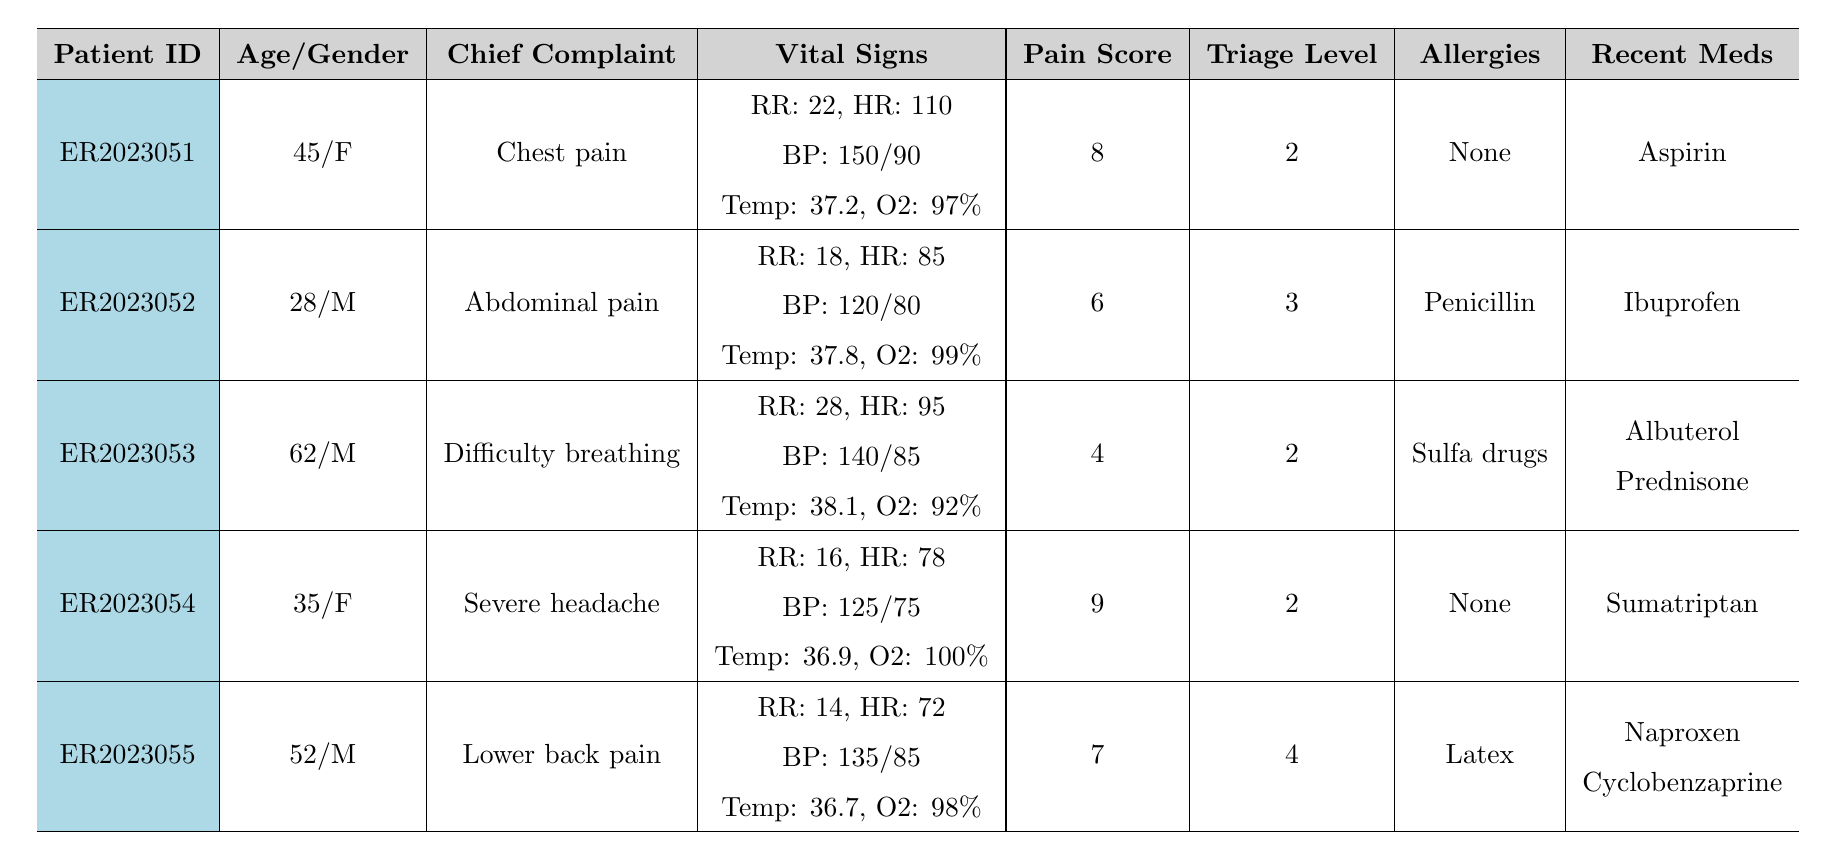What's the chief complaint of patient ER2023051? Patient ER2023051 has the chief complaint of "Chest pain," which is listed directly in the table under the respective patient's information.
Answer: Chest pain What is the triage level of the patient who arrived with severe headache? The patient with the complaint "Severe headache" is identified as ER2023054, and their triage level is noted as '2' in the table.
Answer: 2 How many patients reported a pain score of 8 or higher? By reviewing the pain scores listed, patients ER2023051 (8), ER2023054 (9), and ER2023055 (7) are considered. Thus, two patients reported a pain score of 8 or higher.
Answer: 2 Is there any patient with a penicillin allergy? Patient ER2023052 has a penicillin allergy, as indicated in their allergy status in the table.
Answer: Yes Which patient had the highest heart rate? The highest heart rate is noted for patient ER2023051 with a heart rate of 110, compared to others with lower heart rates.
Answer: ER2023051 What is the average age of the patients with triage level 2? The patients with triage level 2 are ER2023051 (45 years), ER2023053 (62 years), and ER2023054 (35 years). The total age is 45 + 62 + 35 = 142, and the average is 142/3 = 47.33.
Answer: 47.33 How many patients have reported symptoms of nausea? Both patient ER2023051 and ER2023054 have listed nausea as an additional symptom in their records. Therefore, two patients reported nausea.
Answer: 2 Which patient has the lowest blood pressure reading? The lowest blood pressure is for patient ER2023052, with a reading of 120/80, as indicated in the vitals section of the table.
Answer: ER2023052 What is the relationship between pain score and triage level among the patients? Analyzing the data reveals that the pain score does not directly correlate with the triage level, as ER2023054 with a pain score of 9 has a triage level of 2, while ER2023055 with a pain score of 7 has a triage level of 4.
Answer: No direct correlation How many patients reported additional symptoms of shortness of breath? Only patient ER2023051 reported an additional symptom of shortness of breath according to their recorded symptoms in the table.
Answer: 1 